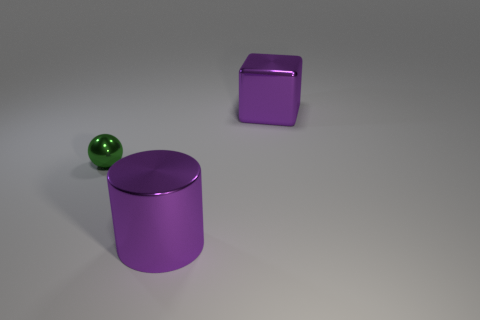Add 1 large yellow metal cylinders. How many objects exist? 4 Subtract all spheres. How many objects are left? 2 Add 2 large purple cylinders. How many large purple cylinders exist? 3 Subtract 1 green balls. How many objects are left? 2 Subtract all large brown blocks. Subtract all green metal spheres. How many objects are left? 2 Add 3 green objects. How many green objects are left? 4 